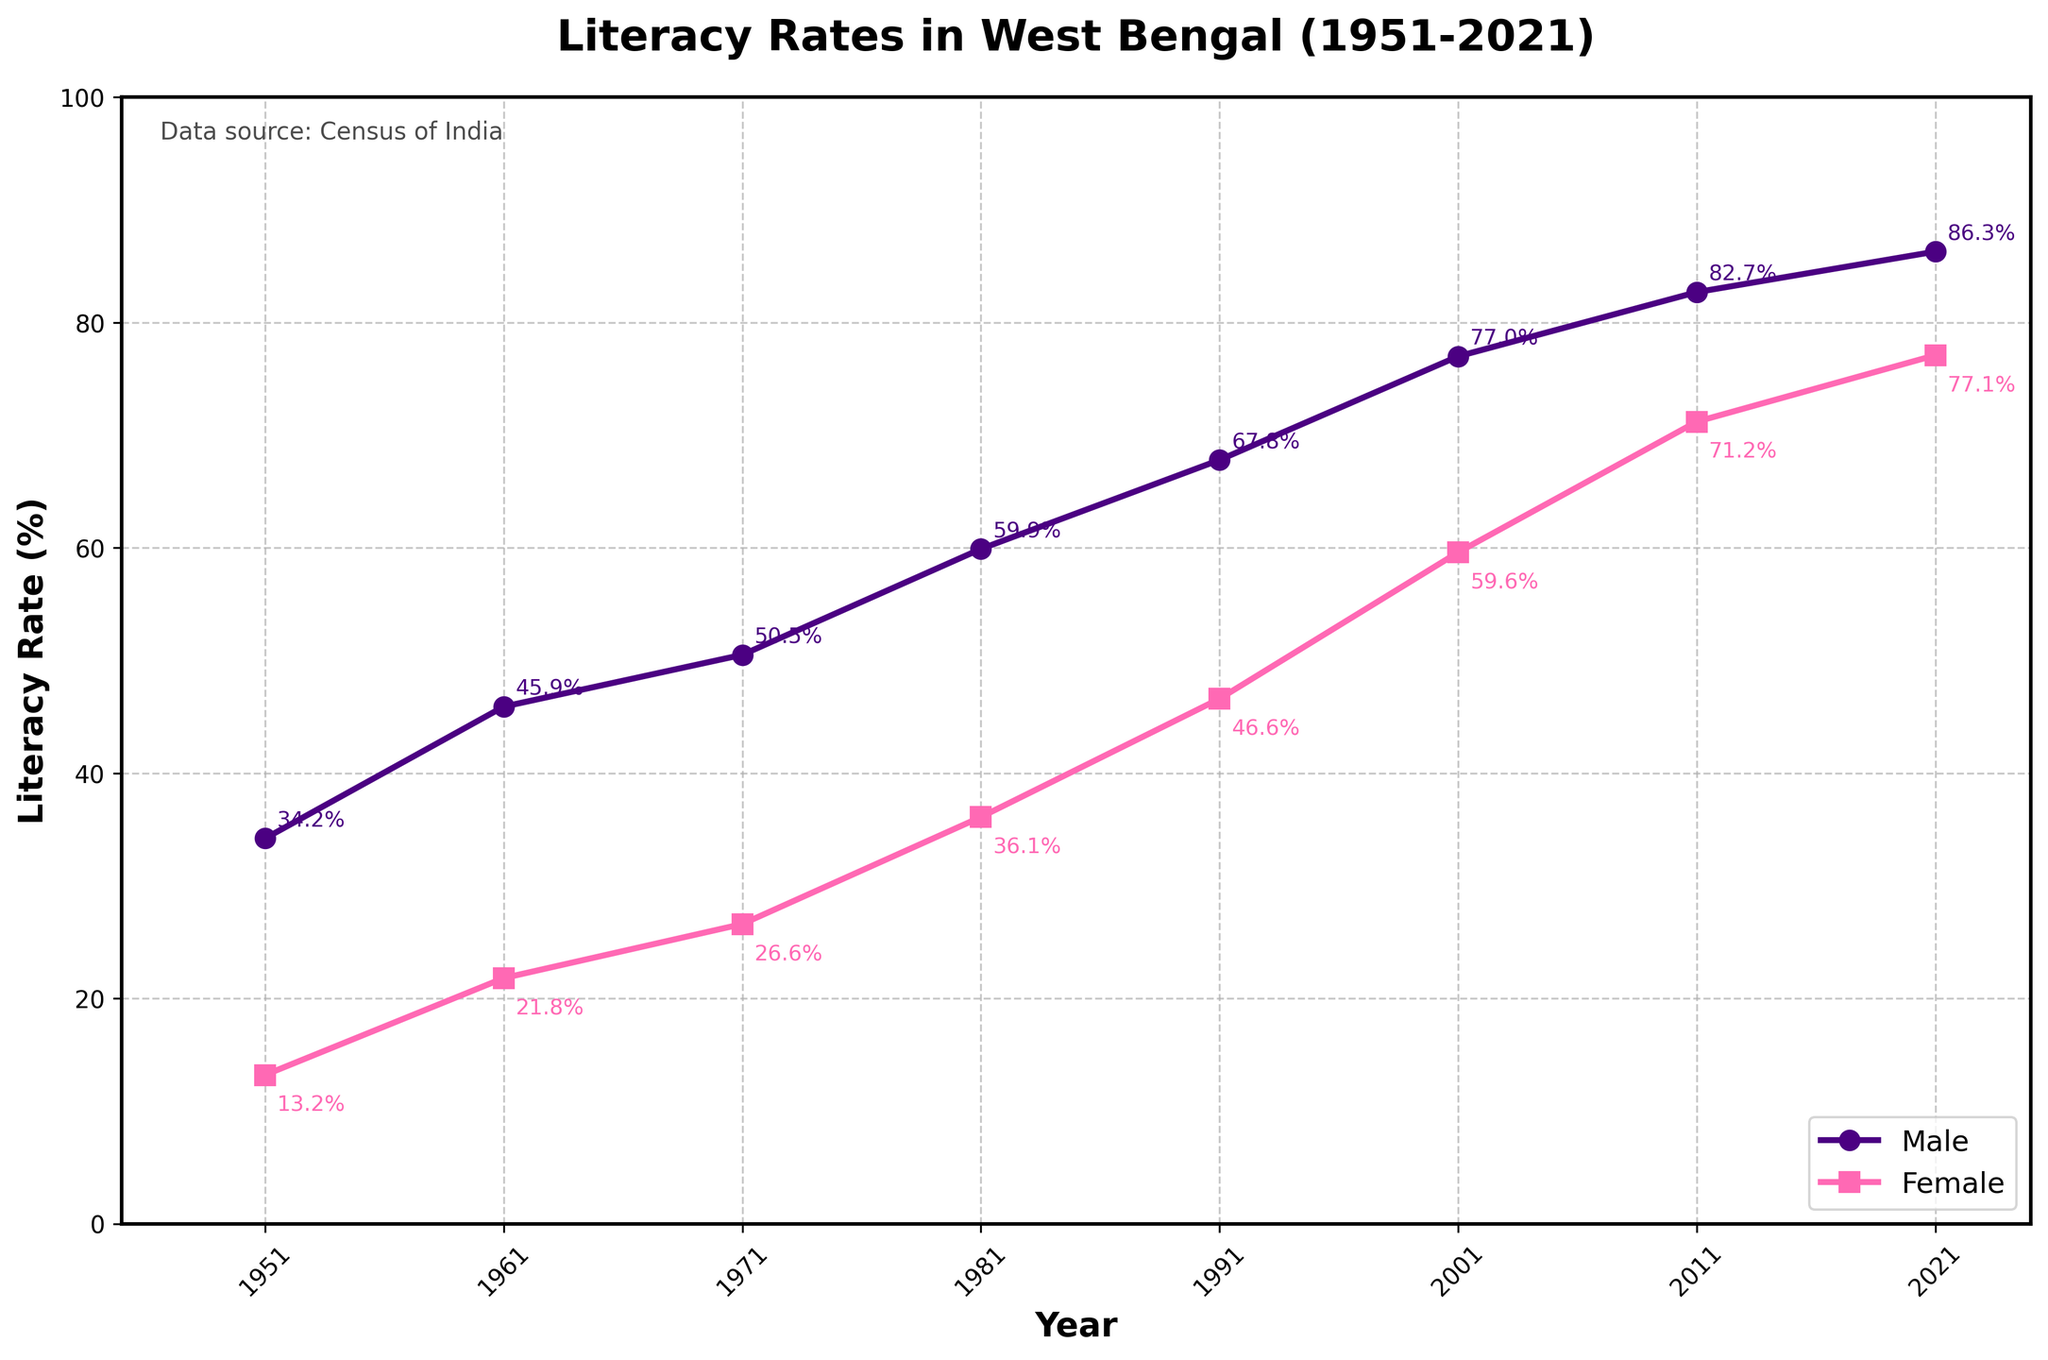Which year had the highest male literacy rate? Look at the plot line for male literacy rates. The highest point on the graph directly indicates the year. It is 2021 with a male literacy rate of 86.3%.
Answer: 2021 What is the difference between the female literacy rates of 2001 and 2011? Observe the female literacy rates for the years 2001 and 2011. Subtract the rate in 2001 (59.6%) from the rate in 2011 (71.2%). The difference is 71.2% - 59.6%.
Answer: 11.6% By how much did the male literacy rate increase from 1951 to 2021? Check the male literacy rates for the years 1951 and 2021. Subtract the initial rate in 1951 (34.2%) from the rate in 2021 (86.3%). The increase is 86.3% - 34.2%.
Answer: 52.1% In which year did the gap between male and female literacy rates narrow the most? Calculate the differences between the male and female literacy rates for each year. The gap is narrowest in 2021, where the difference is 86.3% - 77.1%.
Answer: 2021 Which year had the lowest female literacy rate? Look at the plot line for female literacy rates. The lowest point on the graph is for the year 1951 with a rate of 13.2%.
Answer: 1951 In which decade did the female literacy rate see the highest increase? Determine the differences in female literacy rates between each census year. The highest increase occurred between 2001 and 2011 (71.2% - 59.6%). Each increment per decade can be compared similarly.
Answer: 2001-2011 How does the male literacy rate in 1971 compare to the female literacy rate in 2021? Identify the male literacy rate in 1971 (50.5%) and the female literacy rate in 2021 (77.1%). The female rate in 2021 is significantly higher.
Answer: Female rate in 2021 is higher What is the average male literacy rate from 1951 to 2021? Add up all the male literacy rates from 1951 to 2021 (34.2 + 45.9 + 50.5 + 59.9 + 67.8 + 77.0 + 82.7 + 86.3) and divide by the number of years (8). The sum is 504.3, so the average is 504.3 / 8.
Answer: 63.04% Did the literacy rate for males or females increase more from 1981 to 2001? Calculate the increase for both genders from 1981 to 2001. For males: 77.0% - 59.9% = 17.1%. For females: 59.6% - 36.1% = 23.5%. Compare the increments.
Answer: Females increased more By what percentage did the female literacy rate increase from 1991 to 2021? Subtract the female literacy rate in 1991 (46.6%) from the rate in 2021 (77.1%) and then divide by the 1991 rate. Multiply the result by 100 to get the percentage. (77.1% - 46.6%) / 46.6% * 100.
Answer: 65.52% 